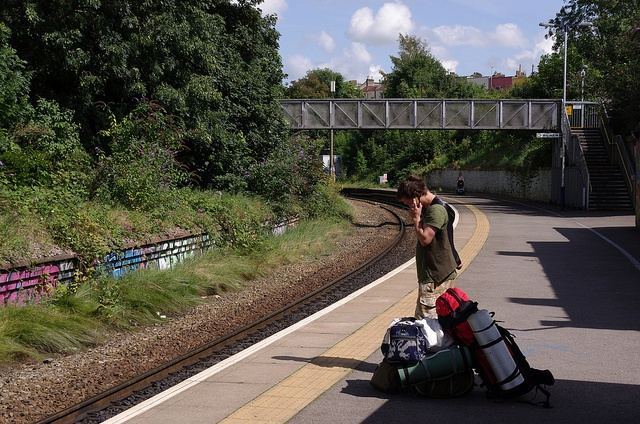Describe the objects in this image and their specific colors. I can see people in black, maroon, and gray tones, backpack in black and gray tones, backpack in black, maroon, red, and darkgray tones, suitcase in black, gray, and darkgreen tones, and backpack in black, gray, navy, and darkgray tones in this image. 